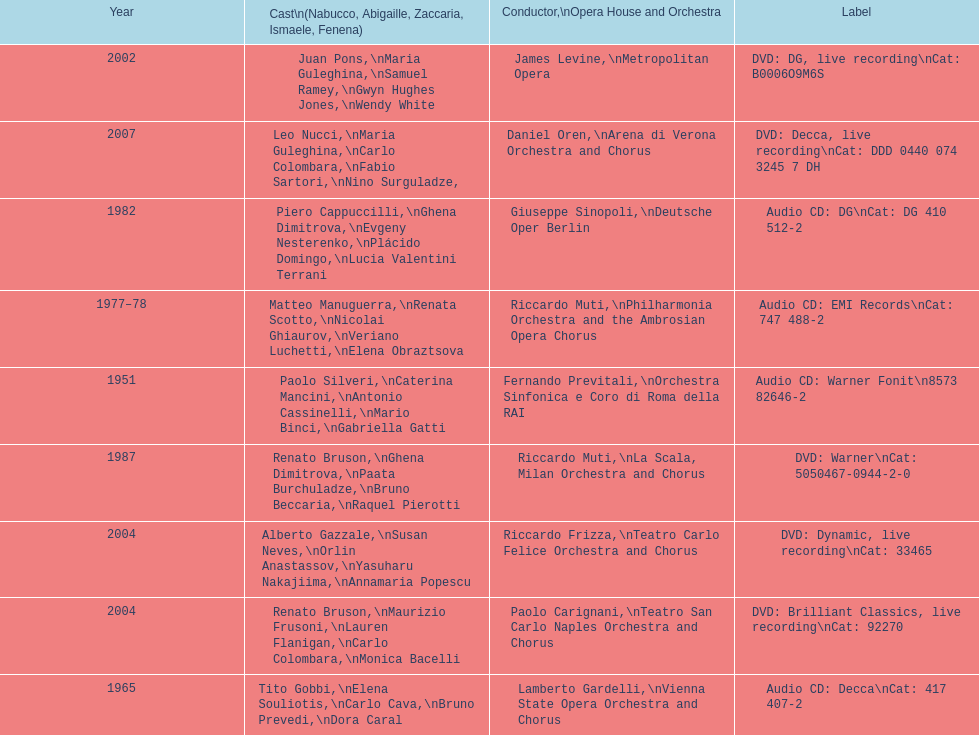How many recordings of nabucco have been made? 9. 